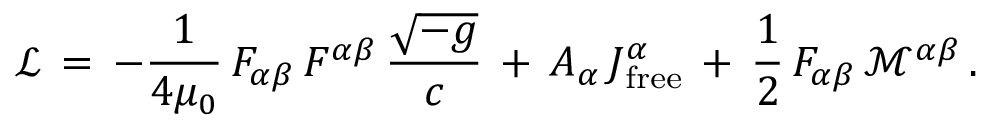<formula> <loc_0><loc_0><loc_500><loc_500>{ \mathcal { L } } \, = \, - { \frac { 1 } { 4 \mu _ { 0 } } } \, F _ { \alpha \beta } \, F ^ { \alpha \beta } \, { \frac { \sqrt { - g } } { c } } \, + \, A _ { \alpha } \, J _ { f r e e } ^ { \alpha } \, + \, { \frac { 1 } { 2 } } \, F _ { \alpha \beta } \, { \mathcal { M } } ^ { \alpha \beta } \, .</formula> 